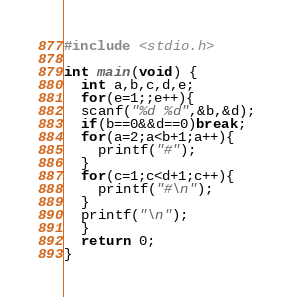Convert code to text. <code><loc_0><loc_0><loc_500><loc_500><_C_>#include <stdio.h>

int main(void) {
  int a,b,c,d,e;
  for(e=1;;e++){
  scanf("%d %d",&b,&d);
  if(b==0&&d==0)break;
  for(a=2;a<b+1;a++){
    printf("#");
  }
  for(c=1;c<d+1;c++){
    printf("#\n");
  }
  printf("\n");
  }
  return 0;
}
</code> 